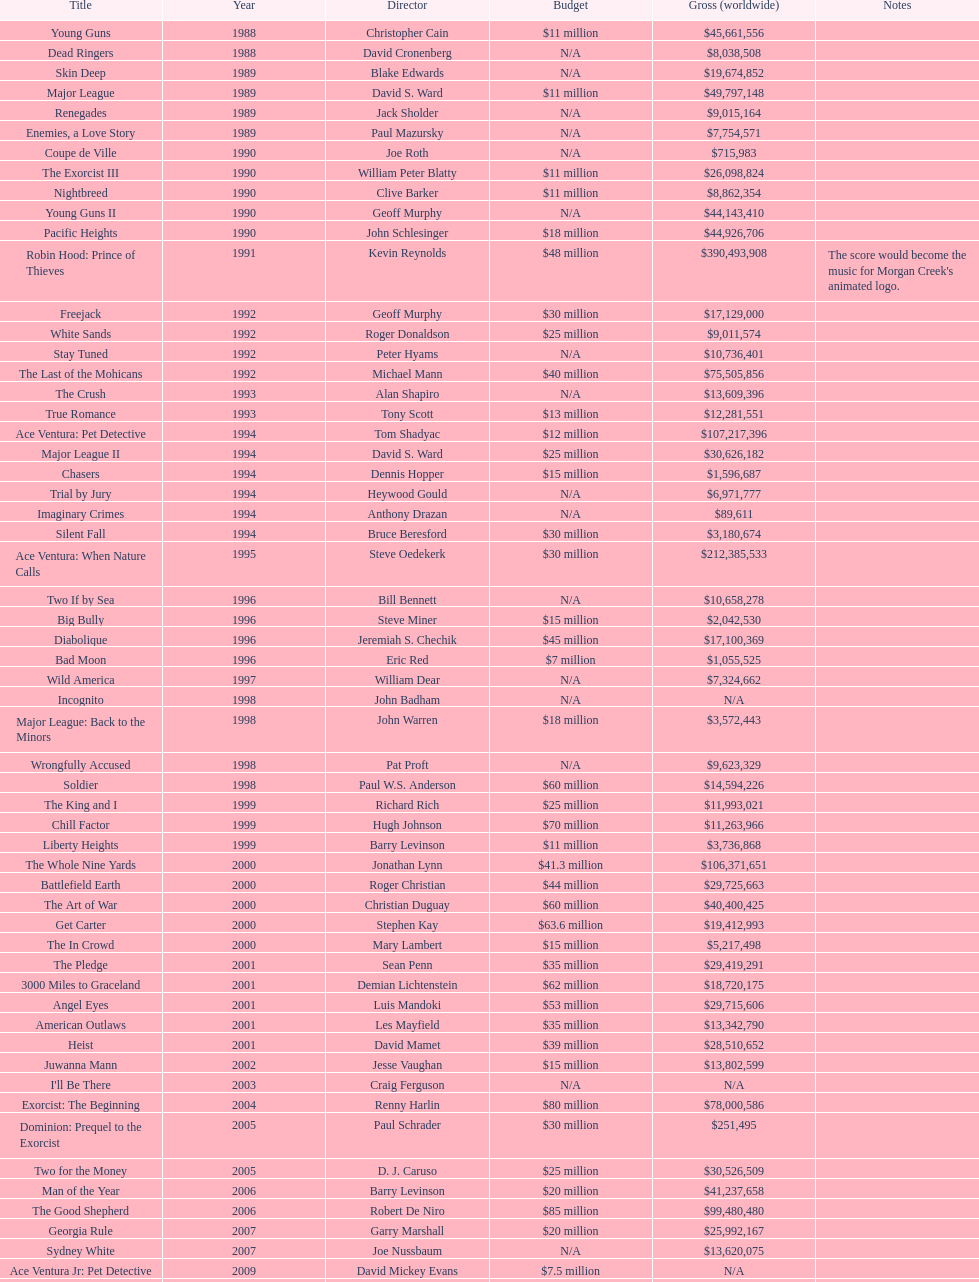Was the budget for young guns more or less than freejack's budget? Less. 